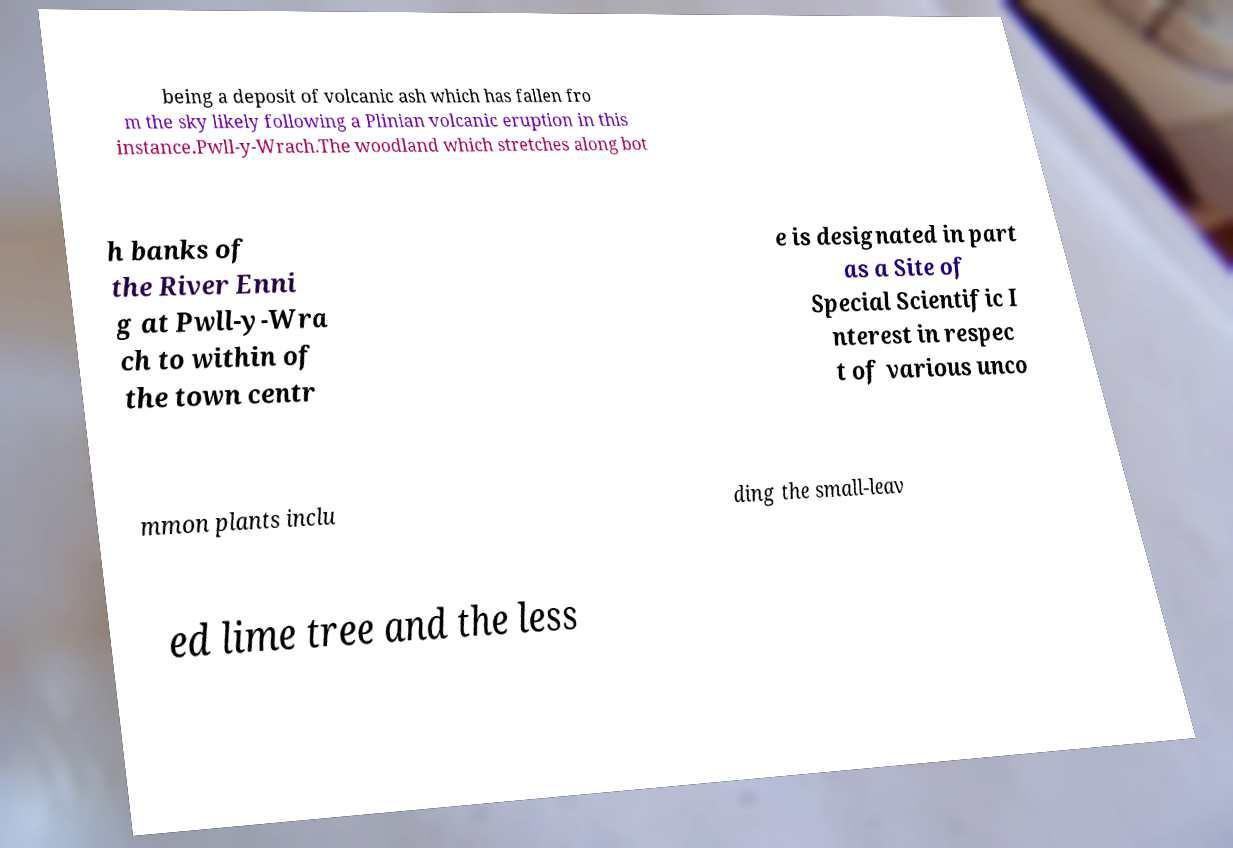I need the written content from this picture converted into text. Can you do that? being a deposit of volcanic ash which has fallen fro m the sky likely following a Plinian volcanic eruption in this instance.Pwll-y-Wrach.The woodland which stretches along bot h banks of the River Enni g at Pwll-y-Wra ch to within of the town centr e is designated in part as a Site of Special Scientific I nterest in respec t of various unco mmon plants inclu ding the small-leav ed lime tree and the less 